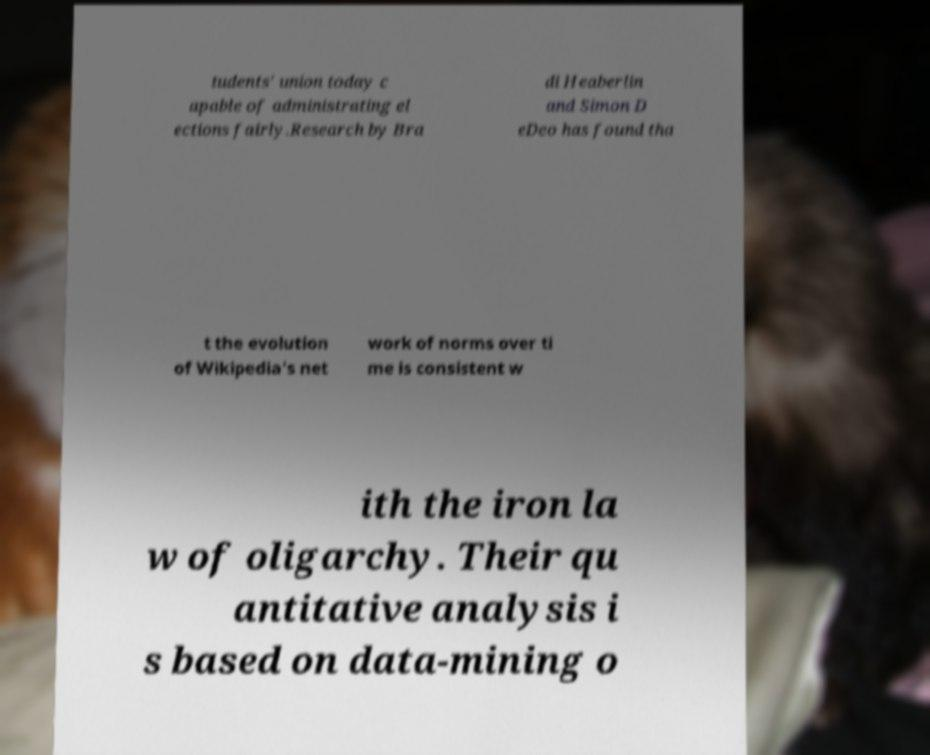Please read and relay the text visible in this image. What does it say? tudents' union today c apable of administrating el ections fairly.Research by Bra di Heaberlin and Simon D eDeo has found tha t the evolution of Wikipedia's net work of norms over ti me is consistent w ith the iron la w of oligarchy. Their qu antitative analysis i s based on data-mining o 